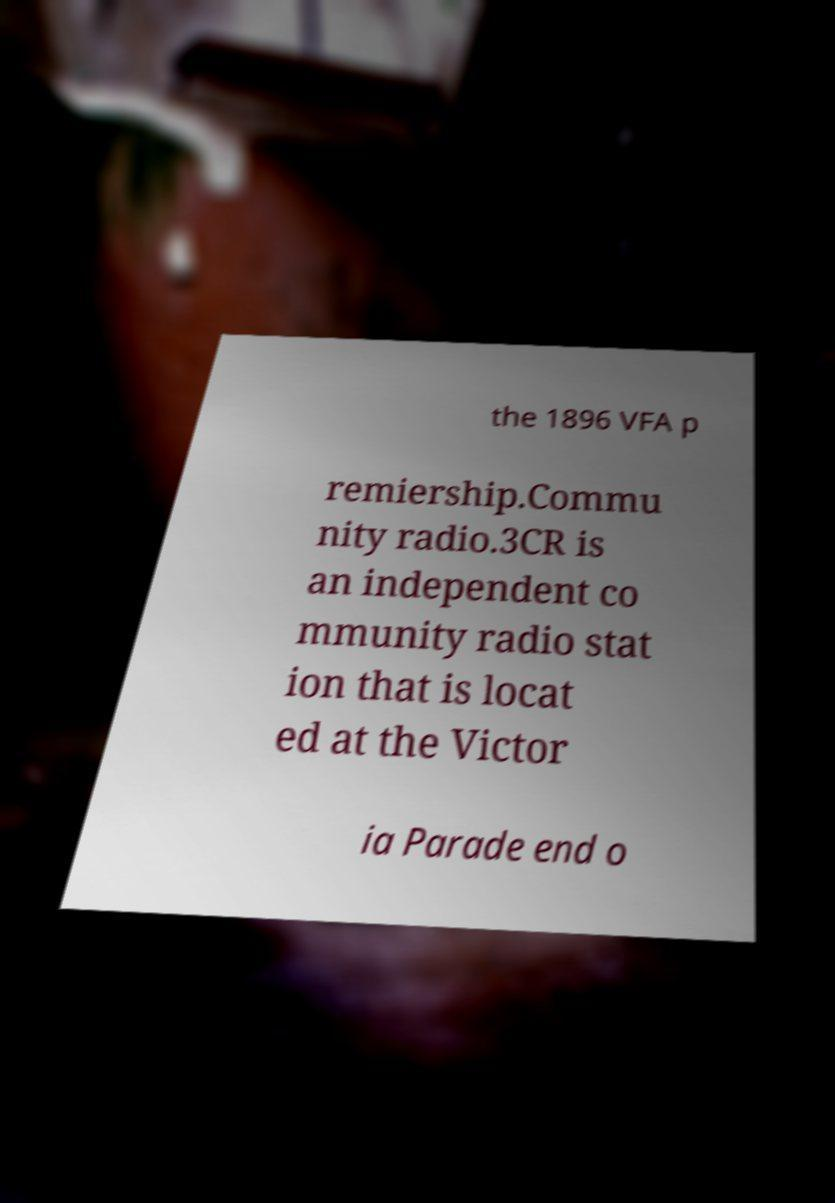I need the written content from this picture converted into text. Can you do that? the 1896 VFA p remiership.Commu nity radio.3CR is an independent co mmunity radio stat ion that is locat ed at the Victor ia Parade end o 